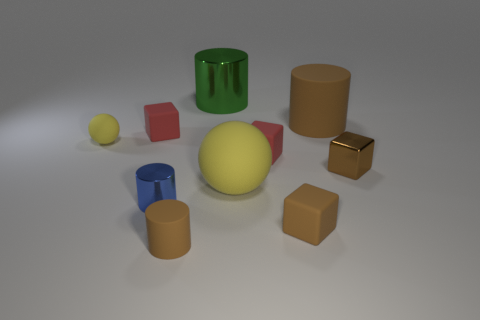Subtract all brown cylinders. How many were subtracted if there are1brown cylinders left? 1 Subtract all big brown cylinders. How many cylinders are left? 3 Subtract all blue blocks. How many brown cylinders are left? 2 Subtract 1 blocks. How many blocks are left? 3 Subtract all brown cylinders. How many cylinders are left? 2 Subtract all cyan cylinders. Subtract all blue blocks. How many cylinders are left? 4 Subtract all blocks. How many objects are left? 6 Subtract all big green shiny cylinders. Subtract all tiny cylinders. How many objects are left? 7 Add 5 large matte spheres. How many large matte spheres are left? 6 Add 3 spheres. How many spheres exist? 5 